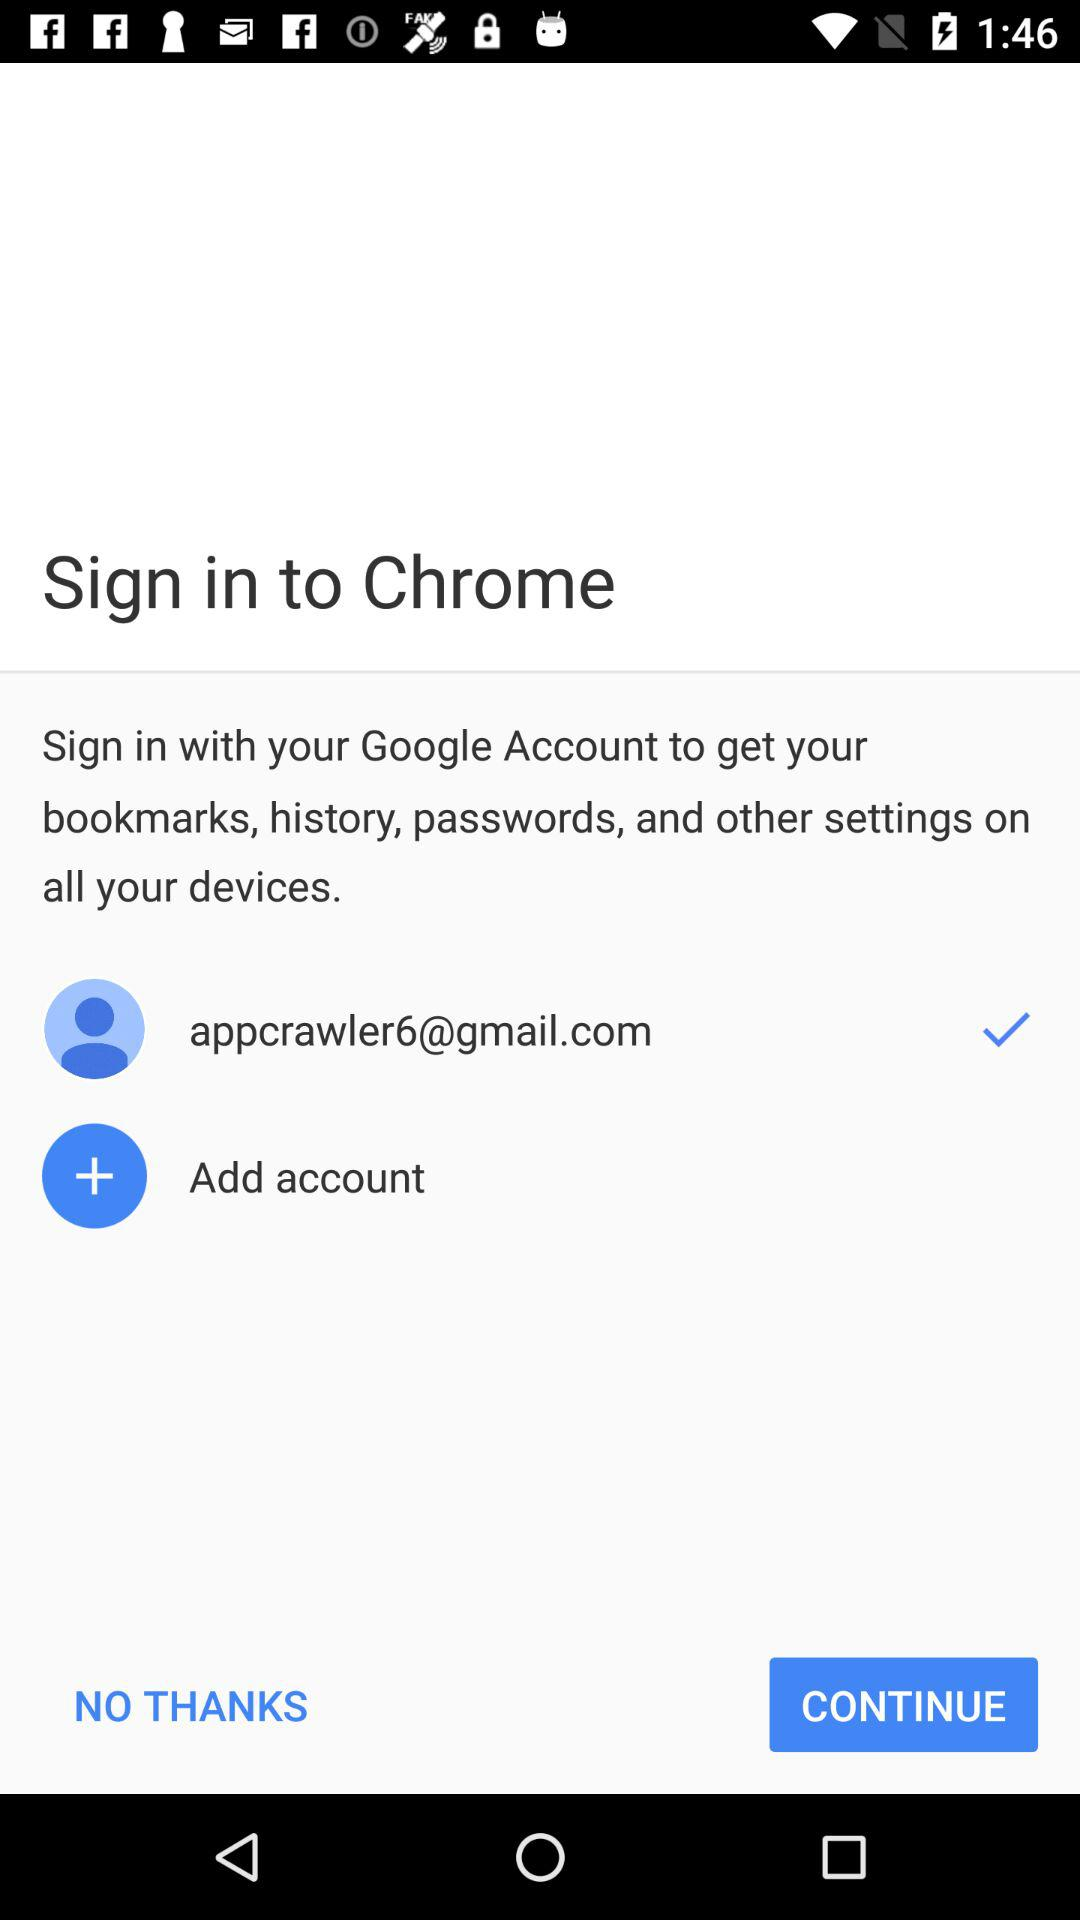Which sites are bookmarked in the account?
When the provided information is insufficient, respond with <no answer>. <no answer> 